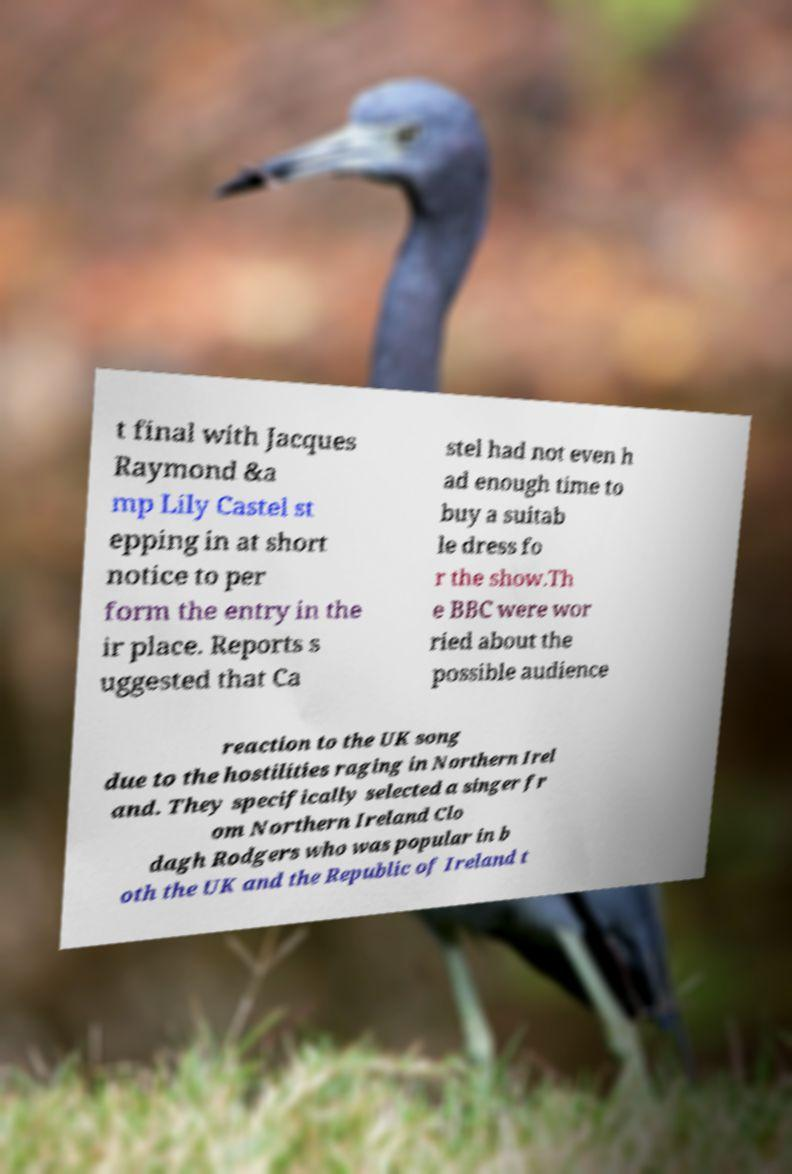Please identify and transcribe the text found in this image. t final with Jacques Raymond &a mp Lily Castel st epping in at short notice to per form the entry in the ir place. Reports s uggested that Ca stel had not even h ad enough time to buy a suitab le dress fo r the show.Th e BBC were wor ried about the possible audience reaction to the UK song due to the hostilities raging in Northern Irel and. They specifically selected a singer fr om Northern Ireland Clo dagh Rodgers who was popular in b oth the UK and the Republic of Ireland t 